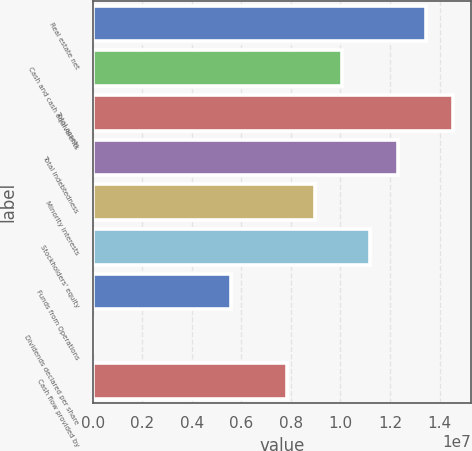<chart> <loc_0><loc_0><loc_500><loc_500><bar_chart><fcel>Real estate net<fcel>Cash and cash equivalents<fcel>Total assets<fcel>Total indebtedness<fcel>Minority interests<fcel>Stockholders' equity<fcel>Funds from Operations<fcel>Dividends declared per share<fcel>Cash flow provided by<nl><fcel>1.34312e+07<fcel>1.00734e+07<fcel>1.45504e+07<fcel>1.23119e+07<fcel>8.95411e+06<fcel>1.11926e+07<fcel>5.59632e+06<fcel>8.7<fcel>7.83485e+06<nl></chart> 